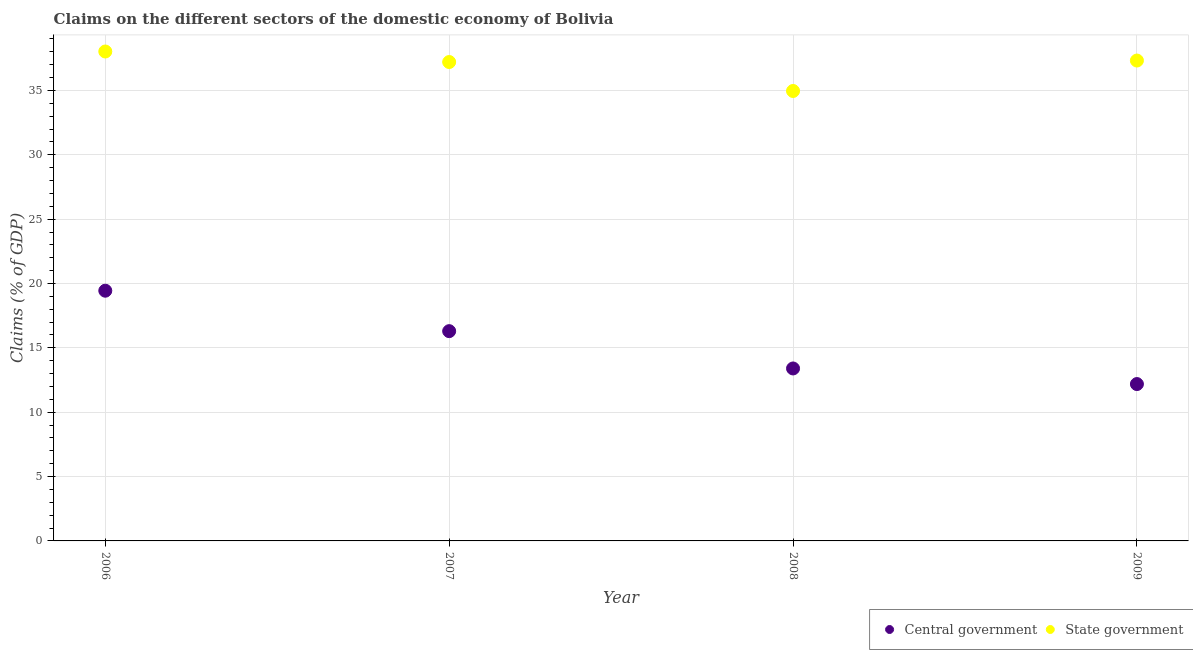Is the number of dotlines equal to the number of legend labels?
Offer a very short reply. Yes. What is the claims on central government in 2007?
Keep it short and to the point. 16.3. Across all years, what is the maximum claims on central government?
Your answer should be compact. 19.44. Across all years, what is the minimum claims on central government?
Keep it short and to the point. 12.19. In which year was the claims on central government maximum?
Make the answer very short. 2006. In which year was the claims on central government minimum?
Your answer should be compact. 2009. What is the total claims on state government in the graph?
Ensure brevity in your answer.  147.52. What is the difference between the claims on central government in 2007 and that in 2008?
Your answer should be very brief. 2.9. What is the difference between the claims on state government in 2007 and the claims on central government in 2006?
Ensure brevity in your answer.  17.77. What is the average claims on central government per year?
Ensure brevity in your answer.  15.33. In the year 2008, what is the difference between the claims on central government and claims on state government?
Make the answer very short. -21.56. What is the ratio of the claims on central government in 2008 to that in 2009?
Offer a very short reply. 1.1. Is the difference between the claims on central government in 2006 and 2007 greater than the difference between the claims on state government in 2006 and 2007?
Your answer should be compact. Yes. What is the difference between the highest and the second highest claims on state government?
Your response must be concise. 0.7. What is the difference between the highest and the lowest claims on state government?
Provide a short and direct response. 3.07. In how many years, is the claims on state government greater than the average claims on state government taken over all years?
Offer a terse response. 3. Is the sum of the claims on central government in 2006 and 2009 greater than the maximum claims on state government across all years?
Give a very brief answer. No. Does the claims on state government monotonically increase over the years?
Offer a very short reply. No. How many dotlines are there?
Your answer should be very brief. 2. Does the graph contain any zero values?
Offer a terse response. No. How are the legend labels stacked?
Provide a short and direct response. Horizontal. What is the title of the graph?
Your response must be concise. Claims on the different sectors of the domestic economy of Bolivia. Does "Resident workers" appear as one of the legend labels in the graph?
Provide a succinct answer. No. What is the label or title of the X-axis?
Ensure brevity in your answer.  Year. What is the label or title of the Y-axis?
Provide a short and direct response. Claims (% of GDP). What is the Claims (% of GDP) of Central government in 2006?
Give a very brief answer. 19.44. What is the Claims (% of GDP) in State government in 2006?
Offer a very short reply. 38.03. What is the Claims (% of GDP) in Central government in 2007?
Your answer should be very brief. 16.3. What is the Claims (% of GDP) of State government in 2007?
Keep it short and to the point. 37.21. What is the Claims (% of GDP) of Central government in 2008?
Make the answer very short. 13.4. What is the Claims (% of GDP) of State government in 2008?
Make the answer very short. 34.96. What is the Claims (% of GDP) in Central government in 2009?
Ensure brevity in your answer.  12.19. What is the Claims (% of GDP) of State government in 2009?
Offer a very short reply. 37.32. Across all years, what is the maximum Claims (% of GDP) of Central government?
Give a very brief answer. 19.44. Across all years, what is the maximum Claims (% of GDP) of State government?
Make the answer very short. 38.03. Across all years, what is the minimum Claims (% of GDP) in Central government?
Provide a succinct answer. 12.19. Across all years, what is the minimum Claims (% of GDP) in State government?
Offer a terse response. 34.96. What is the total Claims (% of GDP) in Central government in the graph?
Keep it short and to the point. 61.33. What is the total Claims (% of GDP) in State government in the graph?
Your answer should be compact. 147.52. What is the difference between the Claims (% of GDP) in Central government in 2006 and that in 2007?
Provide a short and direct response. 3.14. What is the difference between the Claims (% of GDP) of State government in 2006 and that in 2007?
Your response must be concise. 0.82. What is the difference between the Claims (% of GDP) in Central government in 2006 and that in 2008?
Provide a short and direct response. 6.04. What is the difference between the Claims (% of GDP) in State government in 2006 and that in 2008?
Ensure brevity in your answer.  3.07. What is the difference between the Claims (% of GDP) in Central government in 2006 and that in 2009?
Give a very brief answer. 7.25. What is the difference between the Claims (% of GDP) in State government in 2006 and that in 2009?
Your answer should be compact. 0.7. What is the difference between the Claims (% of GDP) in Central government in 2007 and that in 2008?
Give a very brief answer. 2.9. What is the difference between the Claims (% of GDP) of State government in 2007 and that in 2008?
Your response must be concise. 2.25. What is the difference between the Claims (% of GDP) of Central government in 2007 and that in 2009?
Your answer should be very brief. 4.11. What is the difference between the Claims (% of GDP) of State government in 2007 and that in 2009?
Offer a very short reply. -0.12. What is the difference between the Claims (% of GDP) of Central government in 2008 and that in 2009?
Offer a very short reply. 1.21. What is the difference between the Claims (% of GDP) in State government in 2008 and that in 2009?
Your response must be concise. -2.36. What is the difference between the Claims (% of GDP) of Central government in 2006 and the Claims (% of GDP) of State government in 2007?
Make the answer very short. -17.77. What is the difference between the Claims (% of GDP) in Central government in 2006 and the Claims (% of GDP) in State government in 2008?
Your answer should be compact. -15.52. What is the difference between the Claims (% of GDP) of Central government in 2006 and the Claims (% of GDP) of State government in 2009?
Provide a succinct answer. -17.88. What is the difference between the Claims (% of GDP) in Central government in 2007 and the Claims (% of GDP) in State government in 2008?
Provide a succinct answer. -18.66. What is the difference between the Claims (% of GDP) of Central government in 2007 and the Claims (% of GDP) of State government in 2009?
Offer a very short reply. -21.03. What is the difference between the Claims (% of GDP) in Central government in 2008 and the Claims (% of GDP) in State government in 2009?
Offer a very short reply. -23.92. What is the average Claims (% of GDP) of Central government per year?
Offer a very short reply. 15.33. What is the average Claims (% of GDP) of State government per year?
Your response must be concise. 36.88. In the year 2006, what is the difference between the Claims (% of GDP) in Central government and Claims (% of GDP) in State government?
Offer a terse response. -18.59. In the year 2007, what is the difference between the Claims (% of GDP) in Central government and Claims (% of GDP) in State government?
Offer a very short reply. -20.91. In the year 2008, what is the difference between the Claims (% of GDP) of Central government and Claims (% of GDP) of State government?
Keep it short and to the point. -21.56. In the year 2009, what is the difference between the Claims (% of GDP) of Central government and Claims (% of GDP) of State government?
Offer a very short reply. -25.14. What is the ratio of the Claims (% of GDP) of Central government in 2006 to that in 2007?
Give a very brief answer. 1.19. What is the ratio of the Claims (% of GDP) in Central government in 2006 to that in 2008?
Provide a short and direct response. 1.45. What is the ratio of the Claims (% of GDP) in State government in 2006 to that in 2008?
Provide a short and direct response. 1.09. What is the ratio of the Claims (% of GDP) of Central government in 2006 to that in 2009?
Your response must be concise. 1.6. What is the ratio of the Claims (% of GDP) in State government in 2006 to that in 2009?
Keep it short and to the point. 1.02. What is the ratio of the Claims (% of GDP) of Central government in 2007 to that in 2008?
Provide a succinct answer. 1.22. What is the ratio of the Claims (% of GDP) in State government in 2007 to that in 2008?
Keep it short and to the point. 1.06. What is the ratio of the Claims (% of GDP) in Central government in 2007 to that in 2009?
Offer a terse response. 1.34. What is the ratio of the Claims (% of GDP) of Central government in 2008 to that in 2009?
Provide a short and direct response. 1.1. What is the ratio of the Claims (% of GDP) in State government in 2008 to that in 2009?
Ensure brevity in your answer.  0.94. What is the difference between the highest and the second highest Claims (% of GDP) of Central government?
Your answer should be compact. 3.14. What is the difference between the highest and the second highest Claims (% of GDP) of State government?
Provide a short and direct response. 0.7. What is the difference between the highest and the lowest Claims (% of GDP) in Central government?
Your answer should be very brief. 7.25. What is the difference between the highest and the lowest Claims (% of GDP) in State government?
Your response must be concise. 3.07. 